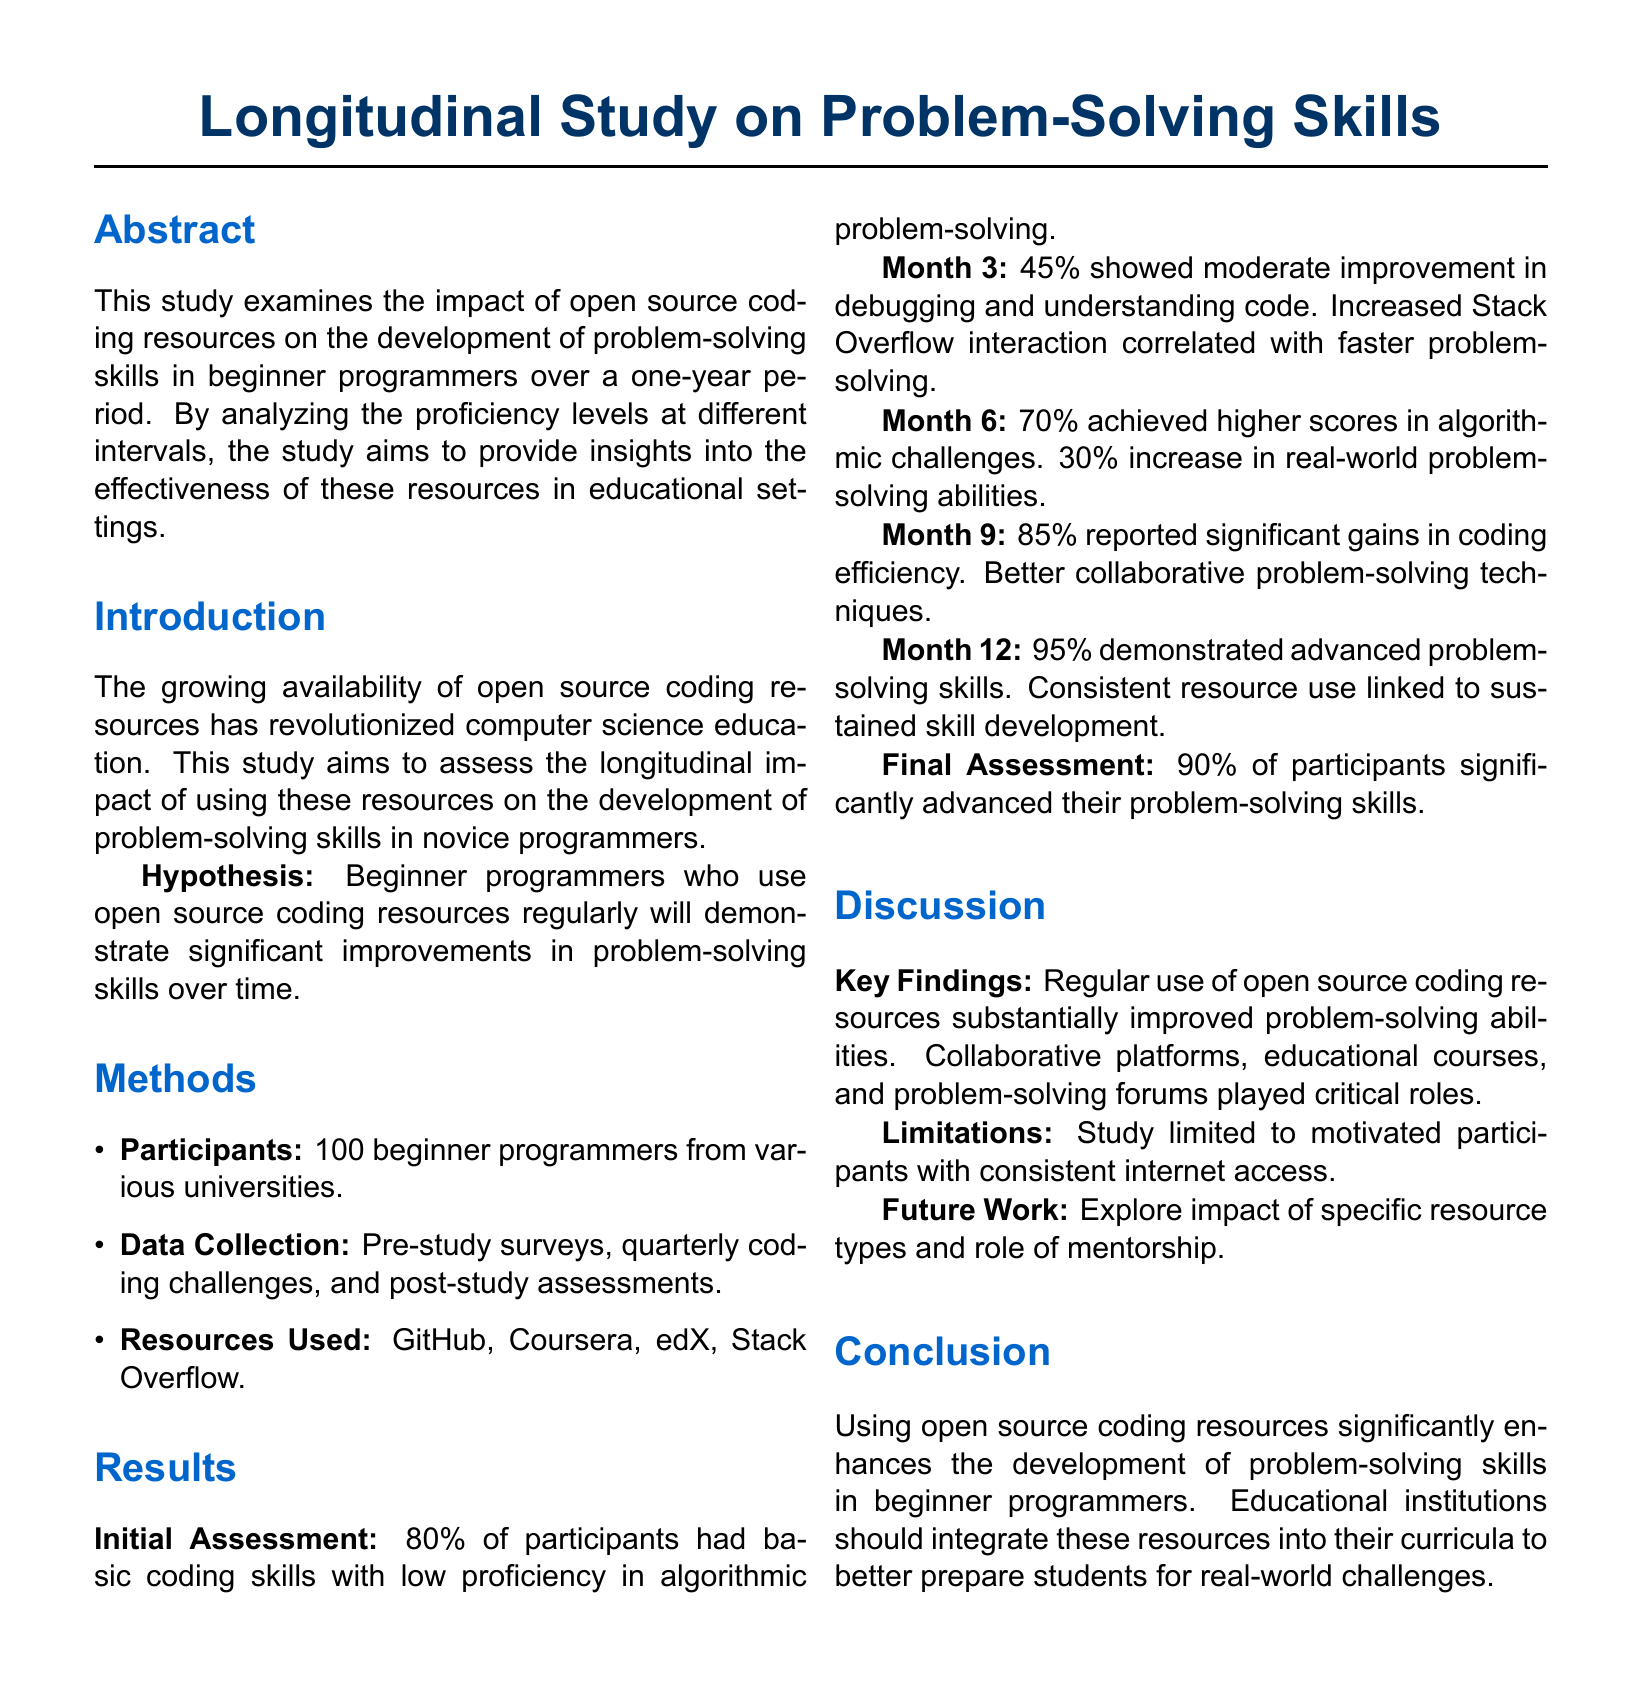What is the focus of the study? The study focuses on the impact of open source coding resources on problem-solving skills.
Answer: Problem-solving skills How many participants were involved in the study? The number of participants mentioned in the document is explicitly stated.
Answer: 100 What percentage of participants showed moderate improvement by month 3? The document provides a specific percentage of participants showing improvement in that time frame.
Answer: 45% What resources were used in the study? The study lists multiple sources utilized for the research, which are part of the results section.
Answer: GitHub, Coursera, edX, Stack Overflow What was the final percentage of participants that demonstrated advanced problem-solving skills? The final assessment provides a summary statistic reflecting participant success.
Answer: 95% What did the study identify as a limitation? The document notes a specific limitation of study participants in relation to their access to technology.
Answer: Internet access What significant outcome was noted about Stack Overflow interaction? The document correlates a specific interaction with a positive outcome on problem-solving.
Answer: Faster problem-solving What is the hypothesis of the study? The hypothesis is identified within the introduction section, indicating expected outcomes.
Answer: Significant improvements in problem-solving skills 